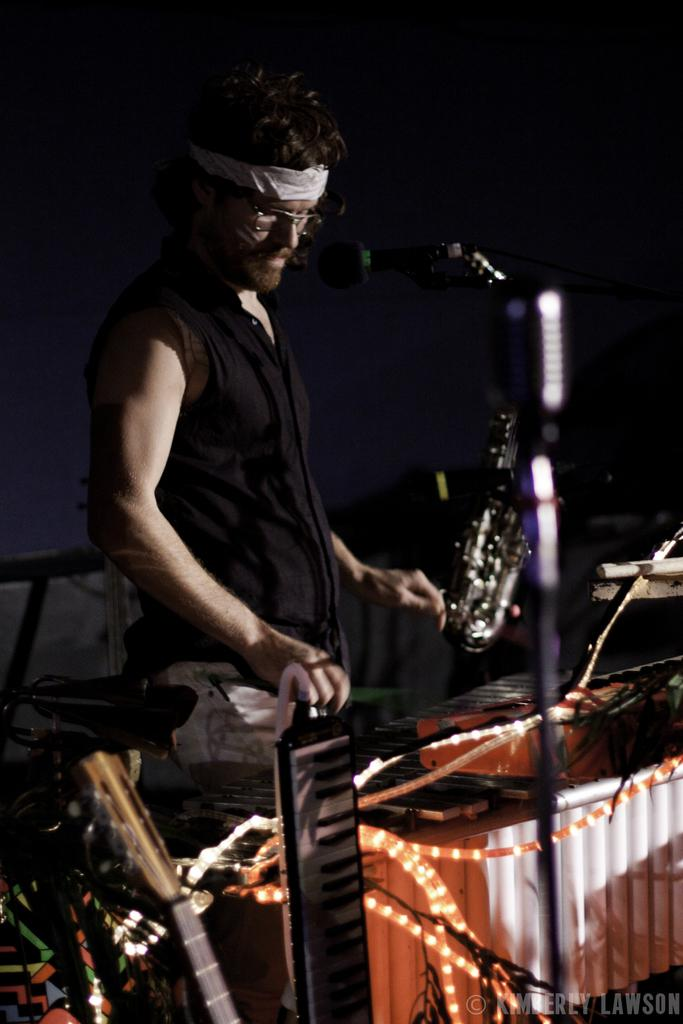Who is the main subject in the image? There is a man in the image. What is the man doing in the image? The man is playing a musical instrument. What device is present for amplifying sound in the image? There is a microphone (mike) in the image. What is the color of the background in the image? The background of the image is dark. What type of seed is the man planting in the image? There is no seed or planting activity present in the image. What rule is the man following while playing the musical instrument in the image? There is no mention of any rules or guidelines related to the man's musical performance in the image. 